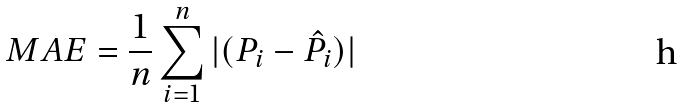Convert formula to latex. <formula><loc_0><loc_0><loc_500><loc_500>M A E = \frac { 1 } { n } \sum _ { i = 1 } ^ { n } | ( P _ { i } - \hat { P } _ { i } ) |</formula> 